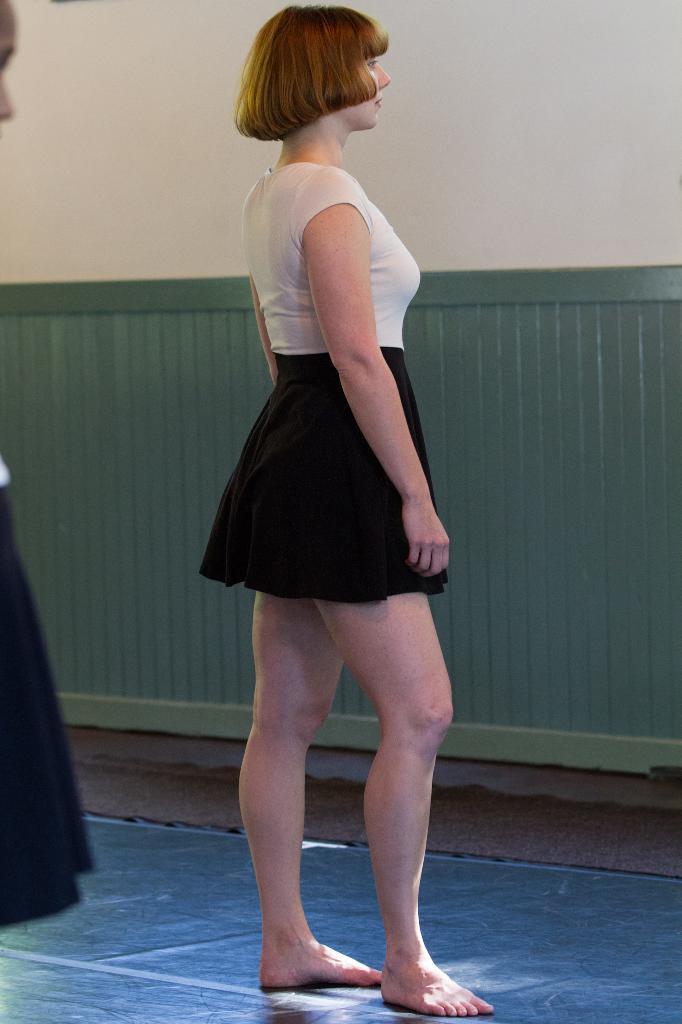Describe this image in one or two sentences. In this image I can see a woman is standing and I can see she is wearing black and white colour dress. On the left side of this image I can see one more person and in the background I can see the wall. 